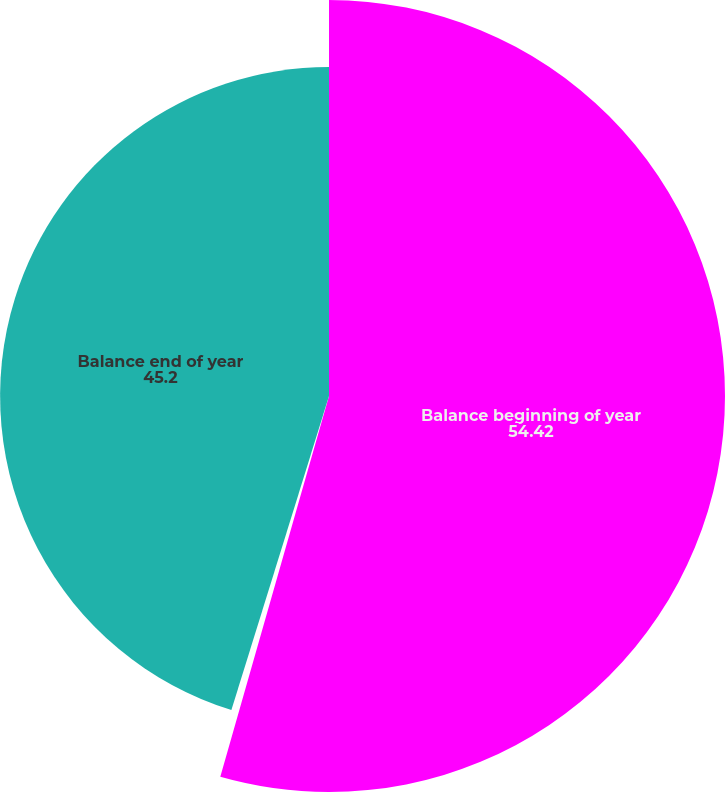Convert chart. <chart><loc_0><loc_0><loc_500><loc_500><pie_chart><fcel>Balance beginning of year<fcel>Changes in engineering<fcel>Balance end of year<nl><fcel>54.42%<fcel>0.37%<fcel>45.2%<nl></chart> 